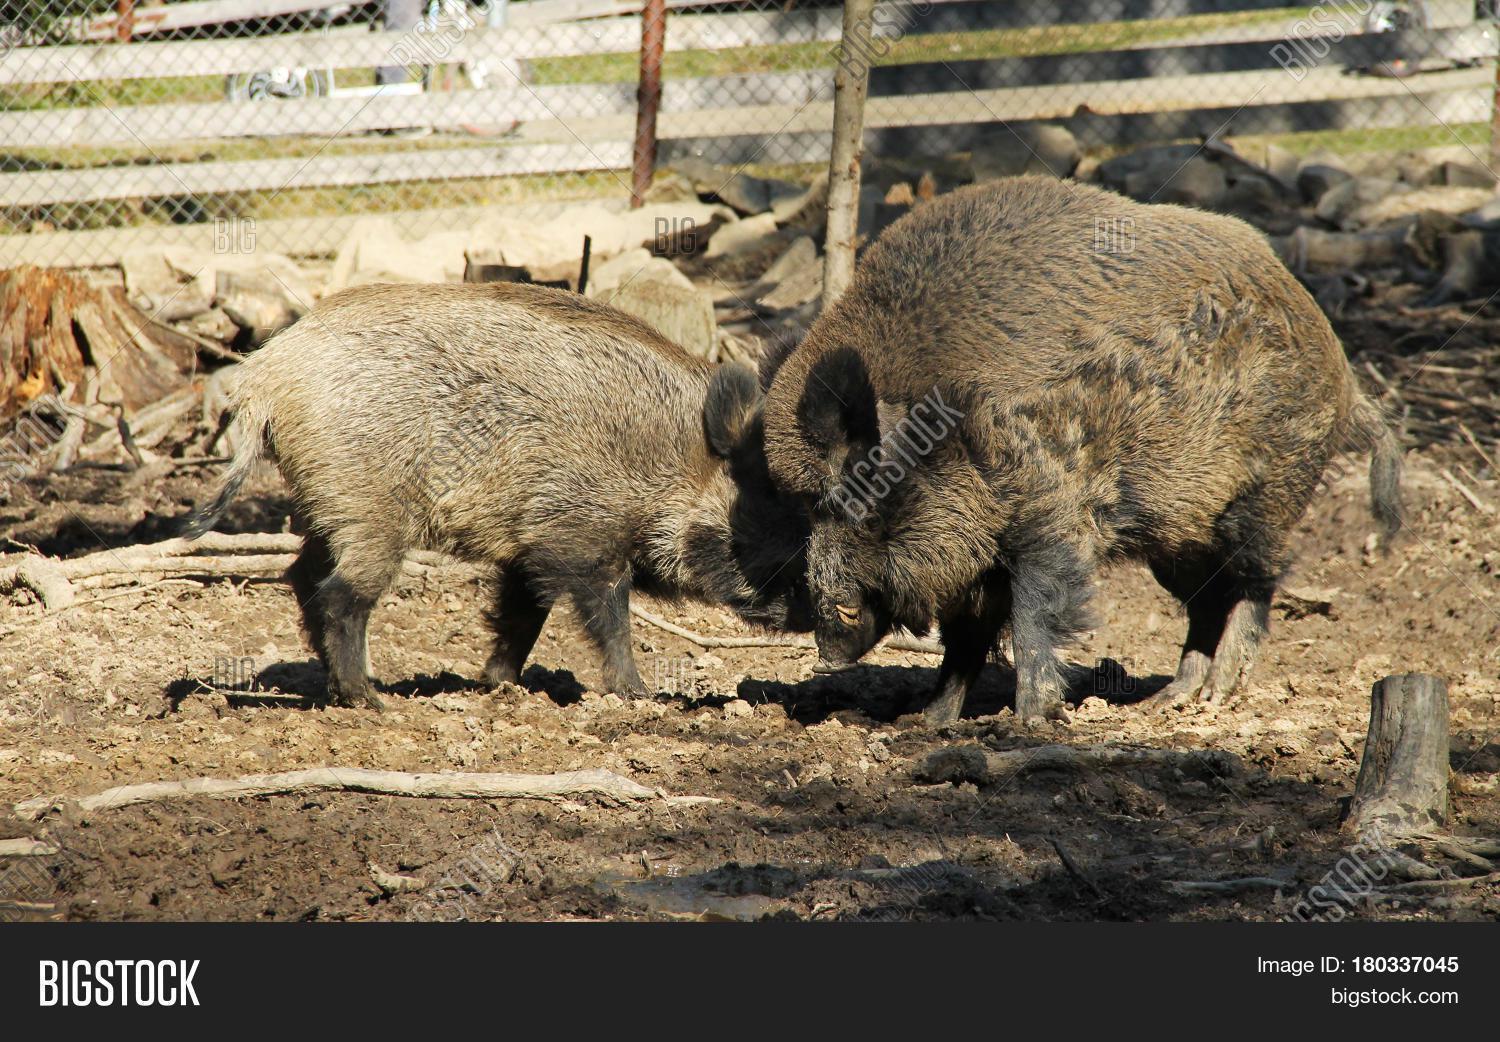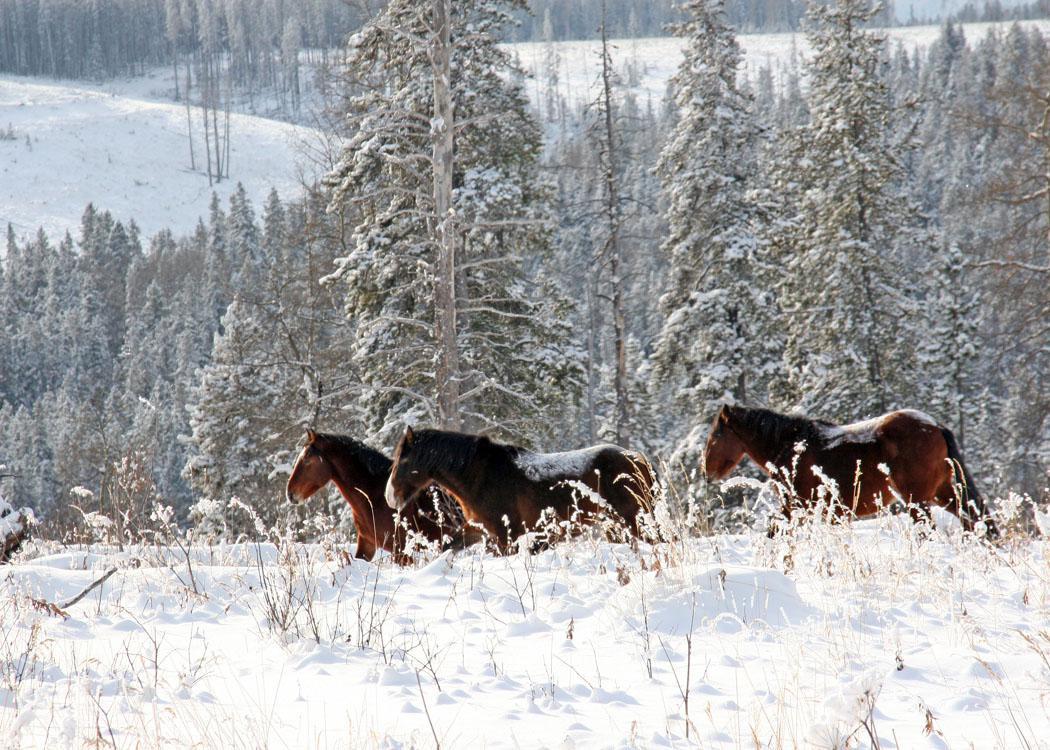The first image is the image on the left, the second image is the image on the right. Analyze the images presented: Is the assertion "Each image shows only one pig and in one of the images that pig is in the mud." valid? Answer yes or no. No. The first image is the image on the left, the second image is the image on the right. For the images shown, is this caption "In the image on the right there is one black wild boar outdoors." true? Answer yes or no. No. 